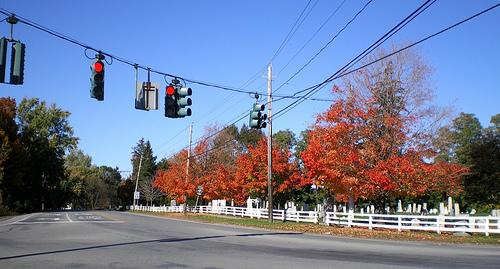Is there anyone walking on the street?
Give a very brief answer. No. What season is it?
Write a very short answer. Fall. What is the color of the traffic light?
Give a very brief answer. Red. 